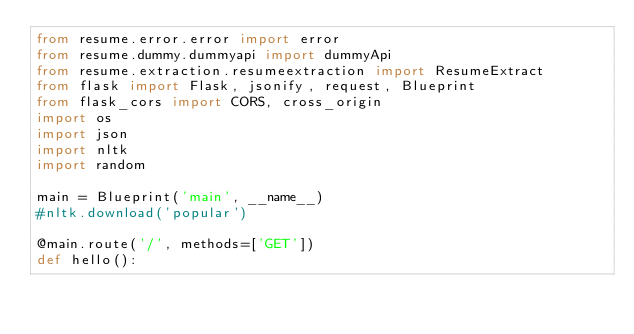Convert code to text. <code><loc_0><loc_0><loc_500><loc_500><_Python_>from resume.error.error import error
from resume.dummy.dummyapi import dummyApi
from resume.extraction.resumeextraction import ResumeExtract
from flask import Flask, jsonify, request, Blueprint
from flask_cors import CORS, cross_origin
import os
import json
import nltk
import random

main = Blueprint('main', __name__)
#nltk.download('popular')

@main.route('/', methods=['GET'])
def hello():</code> 